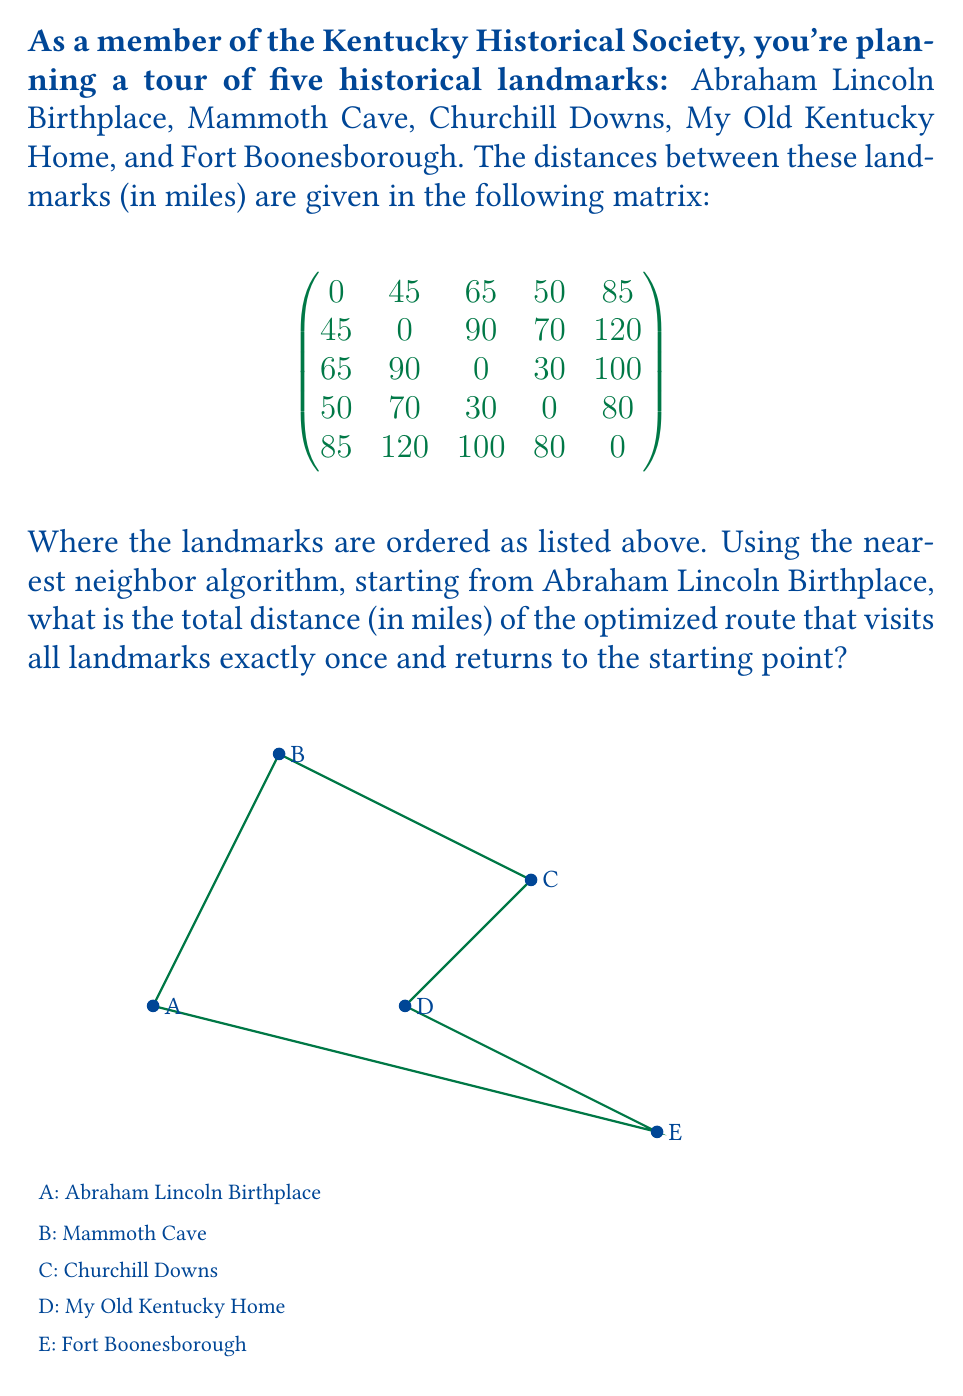Solve this math problem. Let's apply the nearest neighbor algorithm step-by-step:

1) Start at Abraham Lincoln Birthplace (A).

2) Find the nearest unvisited landmark:
   A to B: 45 miles
   A to C: 65 miles
   A to D: 50 miles
   A to E: 85 miles
   The nearest is B (Mammoth Cave) at 45 miles.

3) From B, find the nearest unvisited landmark:
   B to C: 90 miles
   B to D: 70 miles
   B to E: 120 miles
   The nearest is D (My Old Kentucky Home) at 70 miles.

4) From D, find the nearest unvisited landmark:
   D to C: 30 miles
   D to E: 80 miles
   The nearest is C (Churchill Downs) at 30 miles.

5) From C, the only unvisited landmark is E (Fort Boonesborough) at 100 miles.

6) Finally, return to the starting point A from E: 85 miles.

The total distance is the sum of these segments:
$$45 + 70 + 30 + 100 + 85 = 330$$ miles.
Answer: 330 miles 